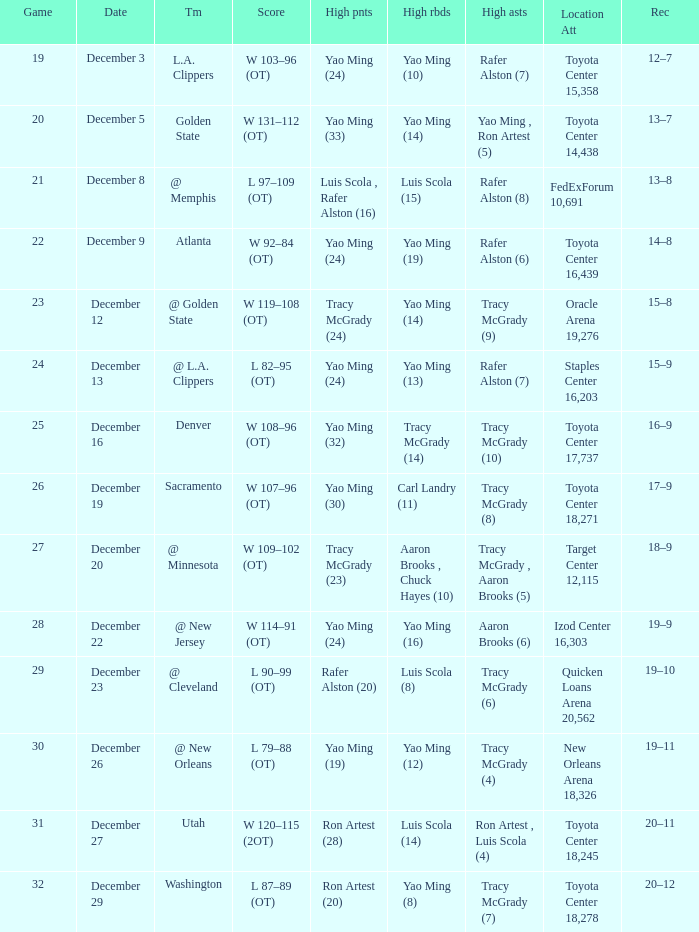When aaron brooks (6) had the highest amount of assists what is the date? December 22. 